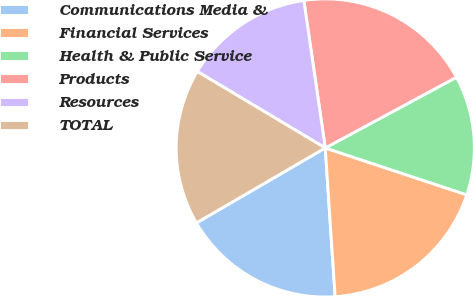Convert chart to OTSL. <chart><loc_0><loc_0><loc_500><loc_500><pie_chart><fcel>Communications Media &<fcel>Financial Services<fcel>Health & Public Service<fcel>Products<fcel>Resources<fcel>TOTAL<nl><fcel>17.67%<fcel>18.85%<fcel>12.96%<fcel>19.43%<fcel>14.13%<fcel>16.96%<nl></chart> 